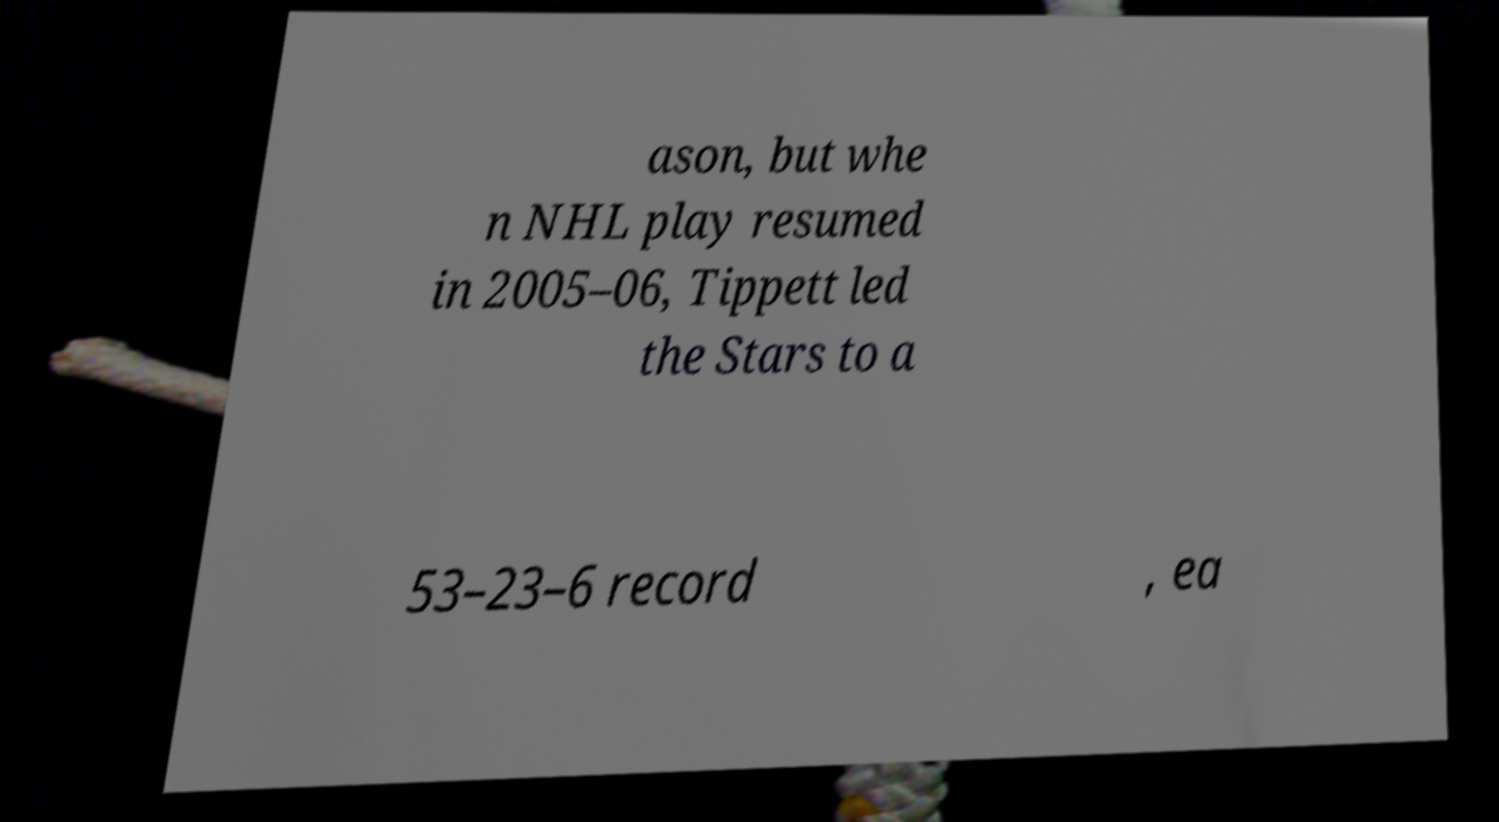Please read and relay the text visible in this image. What does it say? ason, but whe n NHL play resumed in 2005–06, Tippett led the Stars to a 53–23–6 record , ea 